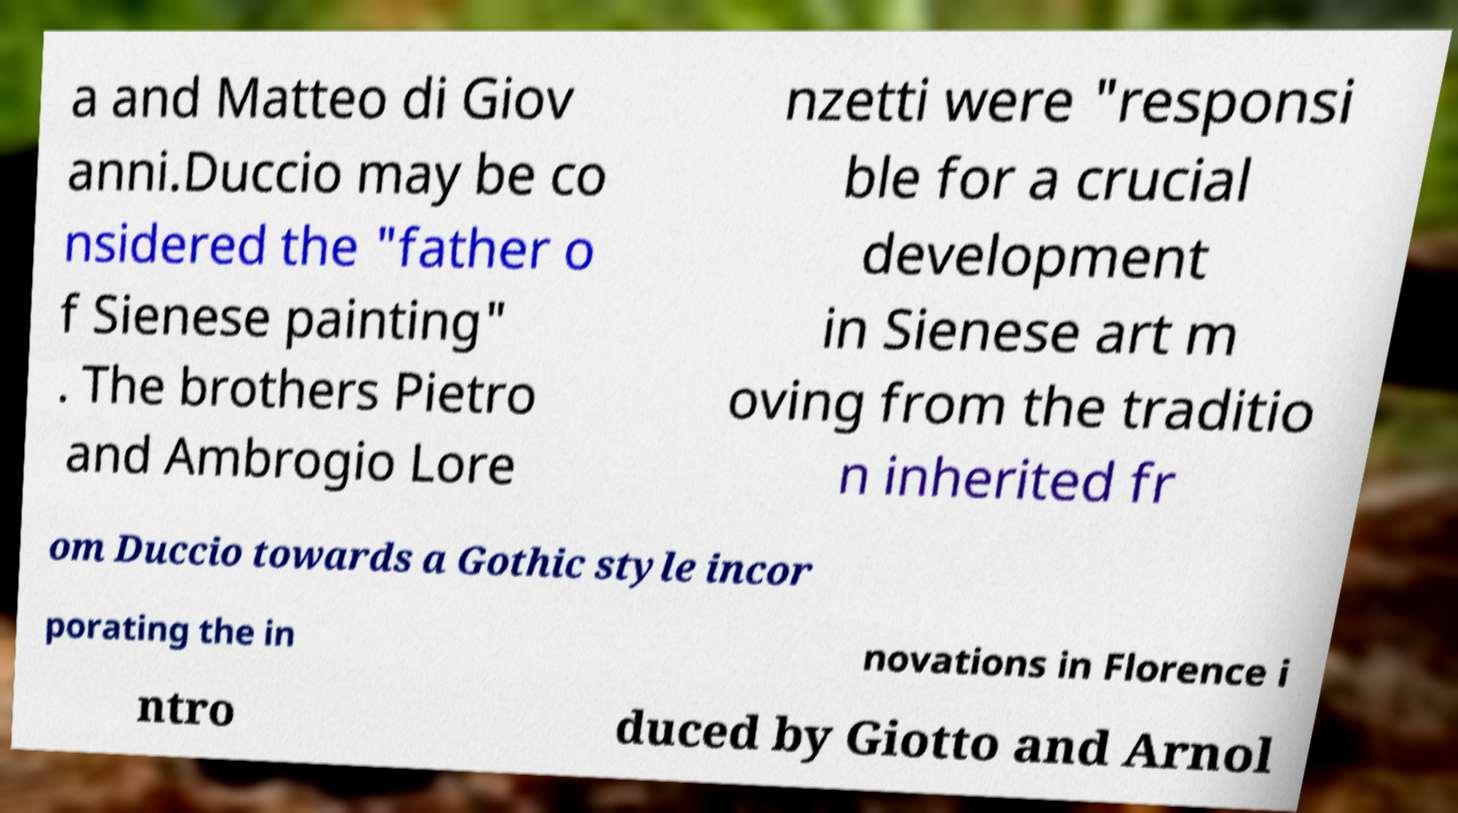Could you assist in decoding the text presented in this image and type it out clearly? a and Matteo di Giov anni.Duccio may be co nsidered the "father o f Sienese painting" . The brothers Pietro and Ambrogio Lore nzetti were "responsi ble for a crucial development in Sienese art m oving from the traditio n inherited fr om Duccio towards a Gothic style incor porating the in novations in Florence i ntro duced by Giotto and Arnol 